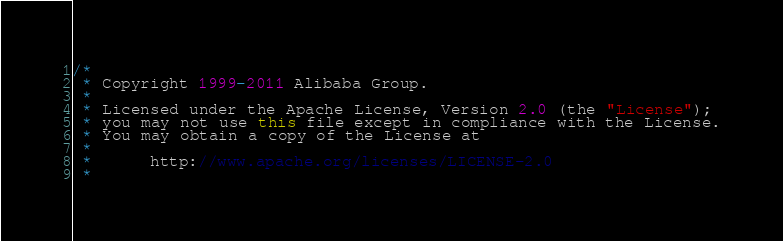Convert code to text. <code><loc_0><loc_0><loc_500><loc_500><_Java_>/*
 * Copyright 1999-2011 Alibaba Group.
 *  
 * Licensed under the Apache License, Version 2.0 (the "License");
 * you may not use this file except in compliance with the License.
 * You may obtain a copy of the License at
 *  
 *      http://www.apache.org/licenses/LICENSE-2.0
 *  </code> 